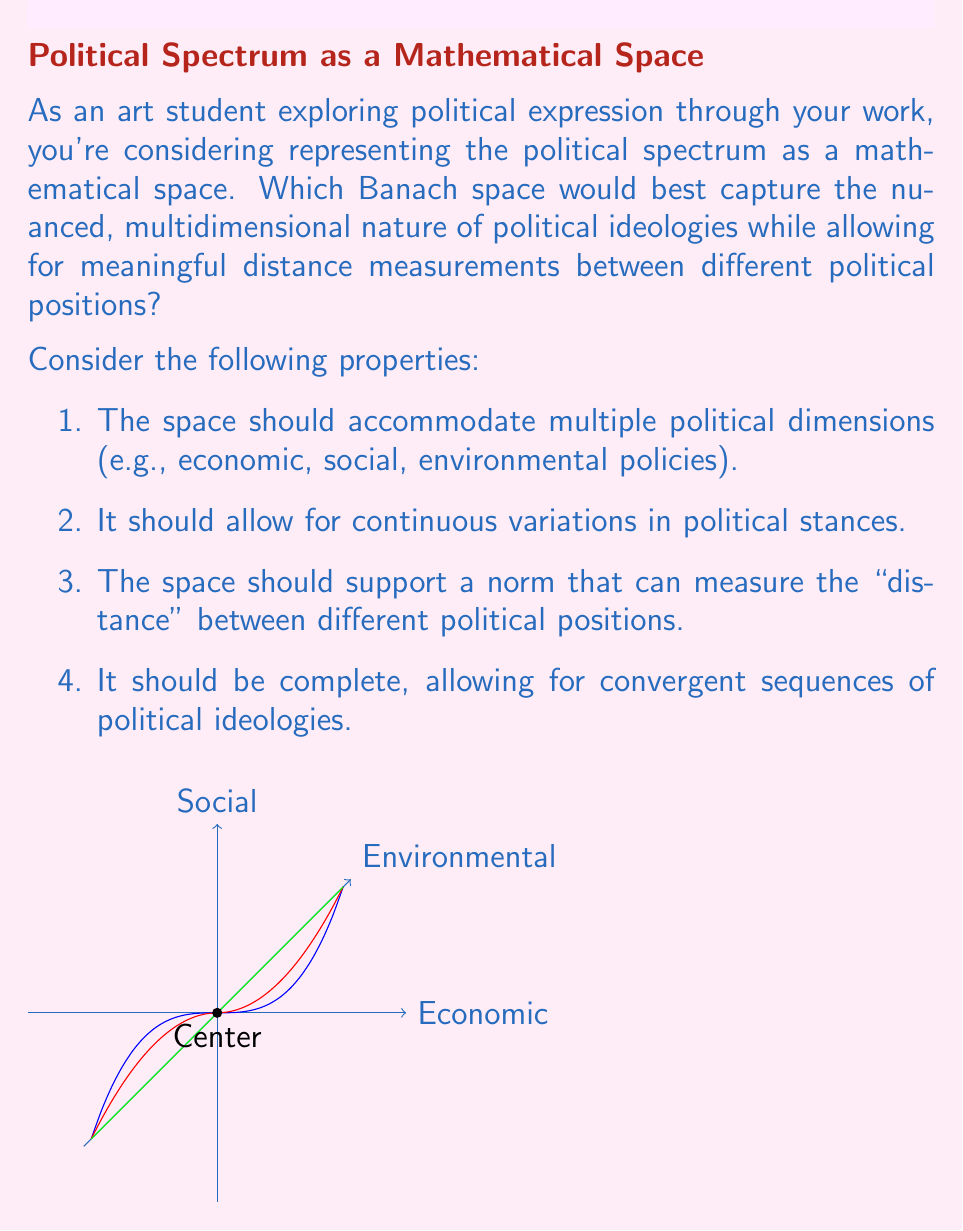Solve this math problem. To determine the most suitable Banach space for representing a political spectrum, let's consider the properties required and analyze potential candidates:

1. Dimensionality: The political spectrum is multidimensional, encompassing various aspects such as economic, social, and environmental policies. This suggests we need a space that can handle multiple dimensions.

2. Continuity: Political stances can vary continuously, rather than discretely. We need a space that allows for continuous functions.

3. Norm and distance: We need a way to measure the "distance" between different political positions, which requires a well-defined norm.

4. Completeness: The space should be complete to allow for convergent sequences of political ideologies.

Given these requirements, let's consider some Banach spaces:

a) $\ell^p$ spaces: While these are complete and have well-defined norms, they are best suited for discrete sequences and may not capture the continuous nature of political ideologies effectively.

b) $L^p$ spaces: These spaces of measurable functions could be suitable, but they may be overly complex for our needs and don't have a natural interpretation for political spectra.

c) $C[0,1]$: The space of continuous functions on $[0,1]$ is too restrictive in terms of dimensionality.

d) $\ell^\infty$: The space of bounded sequences is not ideal for representing continuous political spectra.

e) $C([0,1]^n)$: The space of continuous functions on the n-dimensional unit cube emerges as the most suitable candidate. Here's why:

   - It allows for multiple dimensions (n can be chosen based on the number of political aspects considered).
   - It supports continuous functions, reflecting the continuous nature of political stances.
   - It has a well-defined sup-norm: $\|f\|_\infty = \sup_{x \in [0,1]^n} |f(x)|$, allowing for distance measurements between political positions.
   - It is complete under this norm, satisfying the Banach space requirement.

In this space, each political position can be represented as a function $f: [0,1]^n \to \mathbb{R}$, where each dimension in $[0,1]^n$ corresponds to a different aspect of political ideology (e.g., economic policy, social policy, environmental policy). The value of $f(x)$ at each point $x$ could represent the strength or direction of the stance on those combined issues.

The sup-norm in this space provides a meaningful way to measure the maximum difference between two political positions across all dimensions, which aligns well with how we often consider political differences in practice.
Answer: $C([0,1]^n)$ with sup-norm 